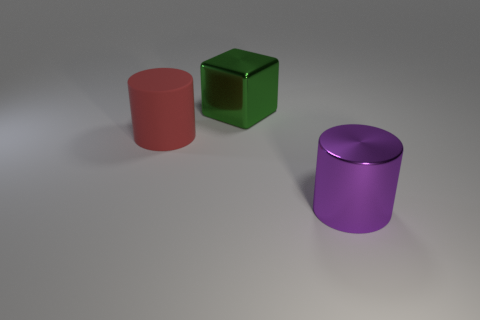The metallic thing that is behind the big shiny thing that is in front of the large red matte object is what color?
Offer a very short reply. Green. There is a metallic object that is the same shape as the big red rubber object; what is its color?
Your answer should be compact. Purple. Is there any other thing that has the same material as the red thing?
Ensure brevity in your answer.  No. What is the material of the cylinder to the left of the big purple metal cylinder?
Provide a short and direct response. Rubber. Are there fewer green blocks that are in front of the purple object than large cyan metallic objects?
Provide a short and direct response. No. There is a shiny object to the left of the metal object in front of the red cylinder; what is its shape?
Make the answer very short. Cube. The large cube is what color?
Give a very brief answer. Green. How many other objects are the same size as the green metallic block?
Provide a short and direct response. 2. What material is the object that is both to the left of the large purple metallic object and in front of the metallic cube?
Offer a very short reply. Rubber. What number of cylinders are behind the large purple shiny cylinder and right of the red object?
Ensure brevity in your answer.  0. 